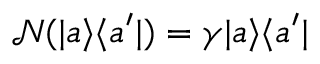<formula> <loc_0><loc_0><loc_500><loc_500>\mathcal { N } ( | a \rangle \langle a ^ { \prime } | ) = \gamma | a \rangle \langle a ^ { \prime } |</formula> 